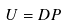<formula> <loc_0><loc_0><loc_500><loc_500>U = D P</formula> 